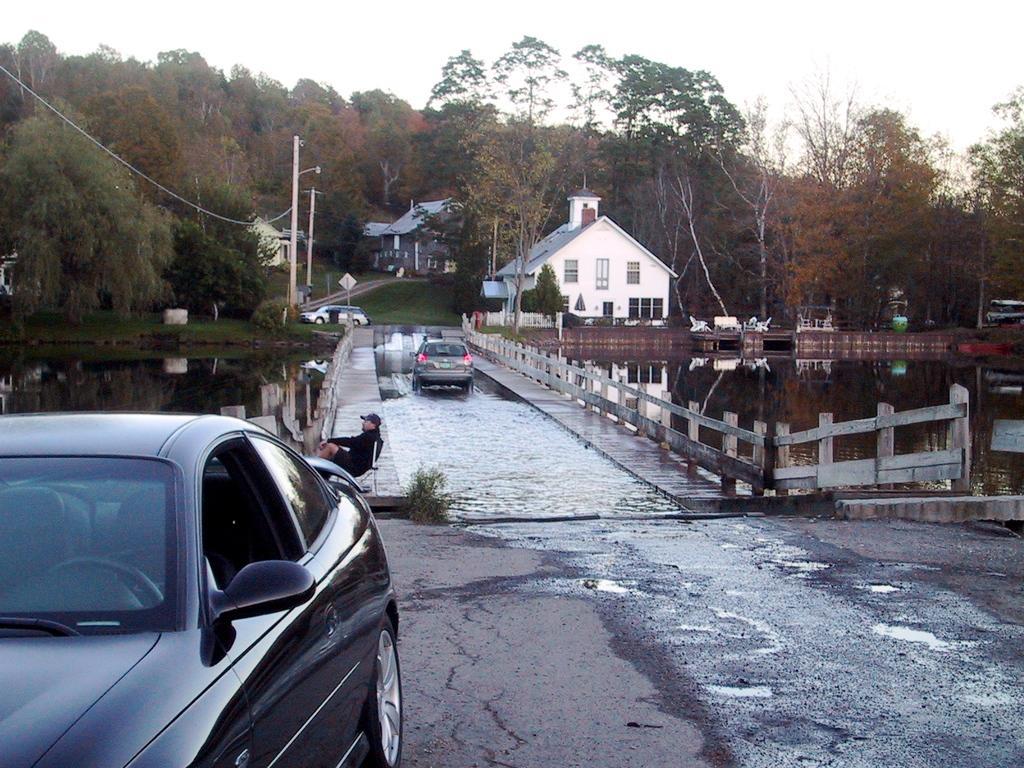How would you summarize this image in a sentence or two? In the center of the image we can see houses, trees, electric light poles, wires, bench, chairs, water, fencing, road, cars, board, grass, a man is sitting on a chair and wearing a cap. At the bottom of the image there is a road. At the top of the image there is a sky. 